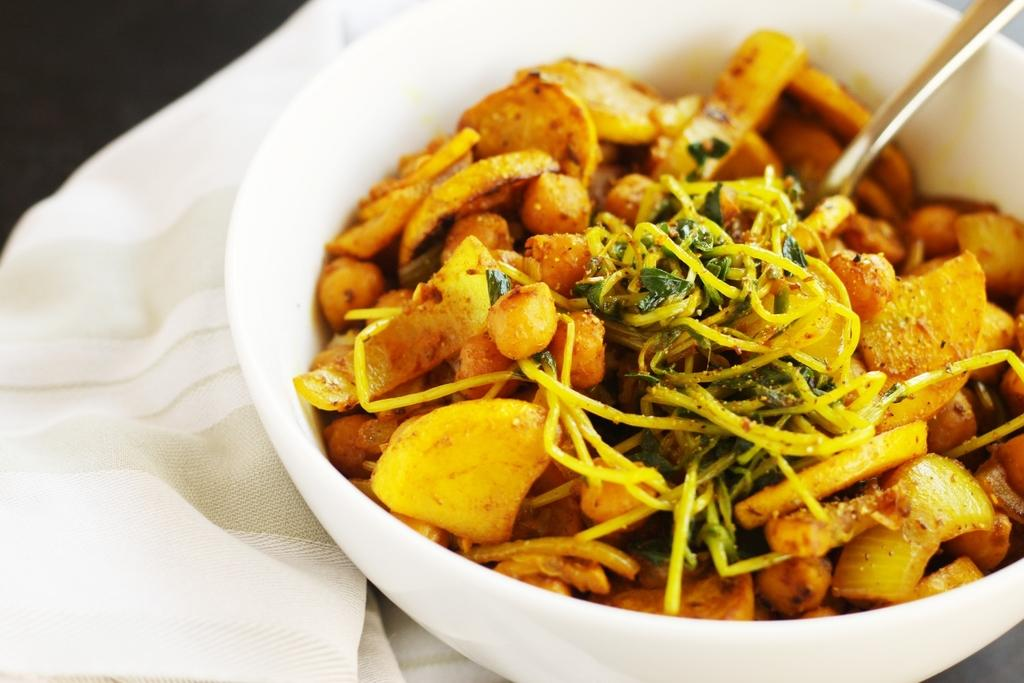What is in the bowl that is visible in the image? The bowl contains food items. What utensil is present in the image? There is a spoon in the image. What color is the cloth on which the bowl is placed? The bowl is placed on a white color cloth. How would you describe the background of the image? The background of the image is dark. Are there any beads visible in the image? There are no beads present in the image. What type of land is depicted in the image? The image does not depict any land; it features a bowl with food items, a spoon, and a white cloth. 